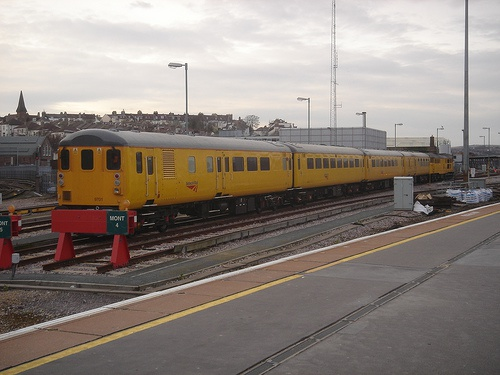Describe the objects in this image and their specific colors. I can see a train in lightgray, olive, black, and maroon tones in this image. 